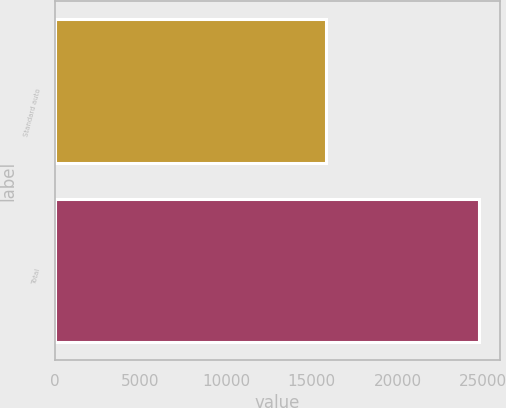Convert chart. <chart><loc_0><loc_0><loc_500><loc_500><bar_chart><fcel>Standard auto<fcel>Total<nl><fcel>15814<fcel>24751<nl></chart> 